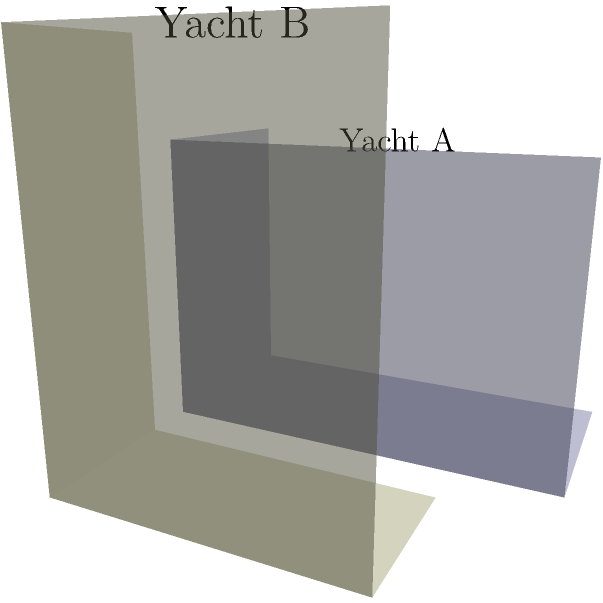As a discerning yacht connoisseur, you're comparing two luxury yacht designs. Yacht A has dimensions of 40m x 20m x 15m, while Yacht B measures 30m x 15m x 20m. Which yacht has a greater volume, and by what percentage is it larger than the other? To solve this problem, we'll follow these steps:

1. Calculate the volume of Yacht A:
   $V_A = 40m \times 20m \times 15m = 12,000 m^3$

2. Calculate the volume of Yacht B:
   $V_B = 30m \times 15m \times 20m = 9,000 m^3$

3. Determine which yacht has the greater volume:
   Yacht A has a volume of $12,000 m^3$, which is greater than Yacht B's $9,000 m^3$.

4. Calculate the percentage difference:
   Percentage difference = $\frac{\text{Difference in volume}}{\text{Smaller volume}} \times 100\%$
   $= \frac{12,000 - 9,000}{9,000} \times 100\%$
   $= \frac{3,000}{9,000} \times 100\%$
   $= 0.3333... \times 100\%$
   $= 33.33\%$

Therefore, Yacht A has a greater volume and is approximately 33.33% larger than Yacht B.
Answer: Yacht A; 33.33% larger 